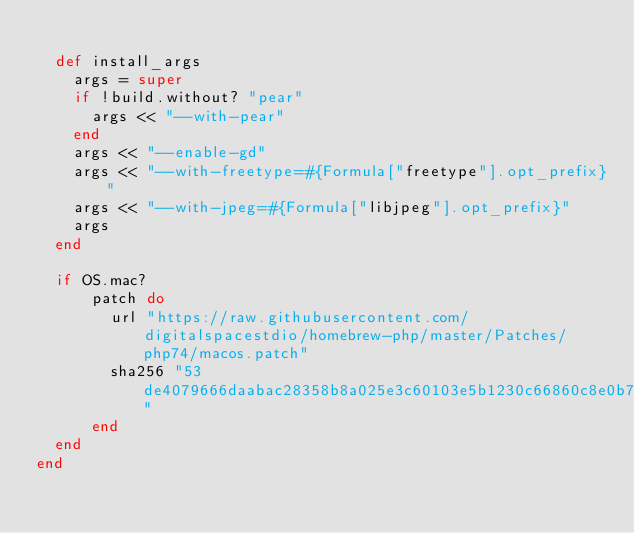Convert code to text. <code><loc_0><loc_0><loc_500><loc_500><_Ruby_>
  def install_args
    args = super
    if !build.without? "pear"
      args << "--with-pear"
    end
    args << "--enable-gd"
    args << "--with-freetype=#{Formula["freetype"].opt_prefix}"
    args << "--with-jpeg=#{Formula["libjpeg"].opt_prefix}"
    args
  end

  if OS.mac?
      patch do
        url "https://raw.githubusercontent.com/digitalspacestdio/homebrew-php/master/Patches/php74/macos.patch"
        sha256 "53de4079666daabac28358b8a025e3c60103e5b1230c66860c8e0b7414c0fec1"
      end
  end
end
</code> 